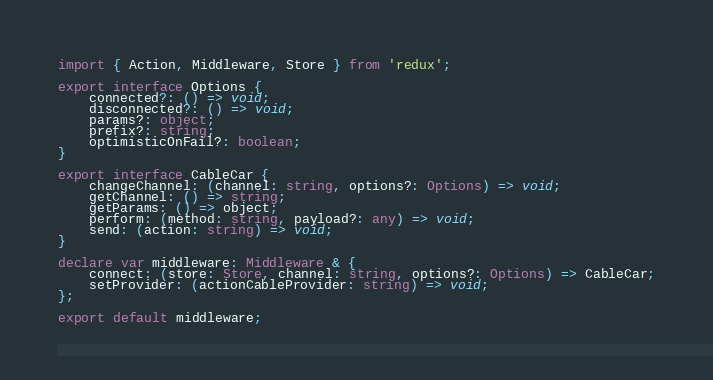Convert code to text. <code><loc_0><loc_0><loc_500><loc_500><_TypeScript_>import { Action, Middleware, Store } from 'redux';

export interface Options {
    connected?: () => void;
    disconnected?: () => void;
    params?: object;
    prefix?: string;
    optimisticOnFail?: boolean;
}

export interface CableCar {
    changeChannel: (channel: string, options?: Options) => void;
    getChannel: () => string;
    getParams: () => object;
    perform: (method: string, payload?: any) => void;
    send: (action: string) => void;
}

declare var middleware: Middleware & {
    connect: (store: Store, channel: string, options?: Options) => CableCar;
    setProvider: (actionCableProvider: string) => void;
};

export default middleware;
</code> 